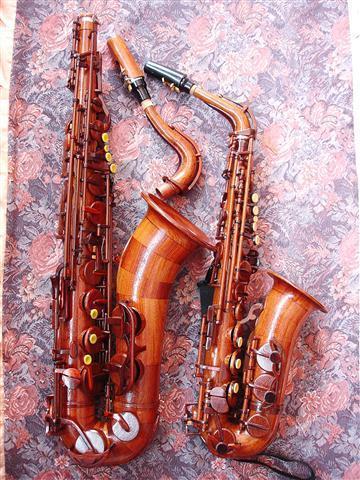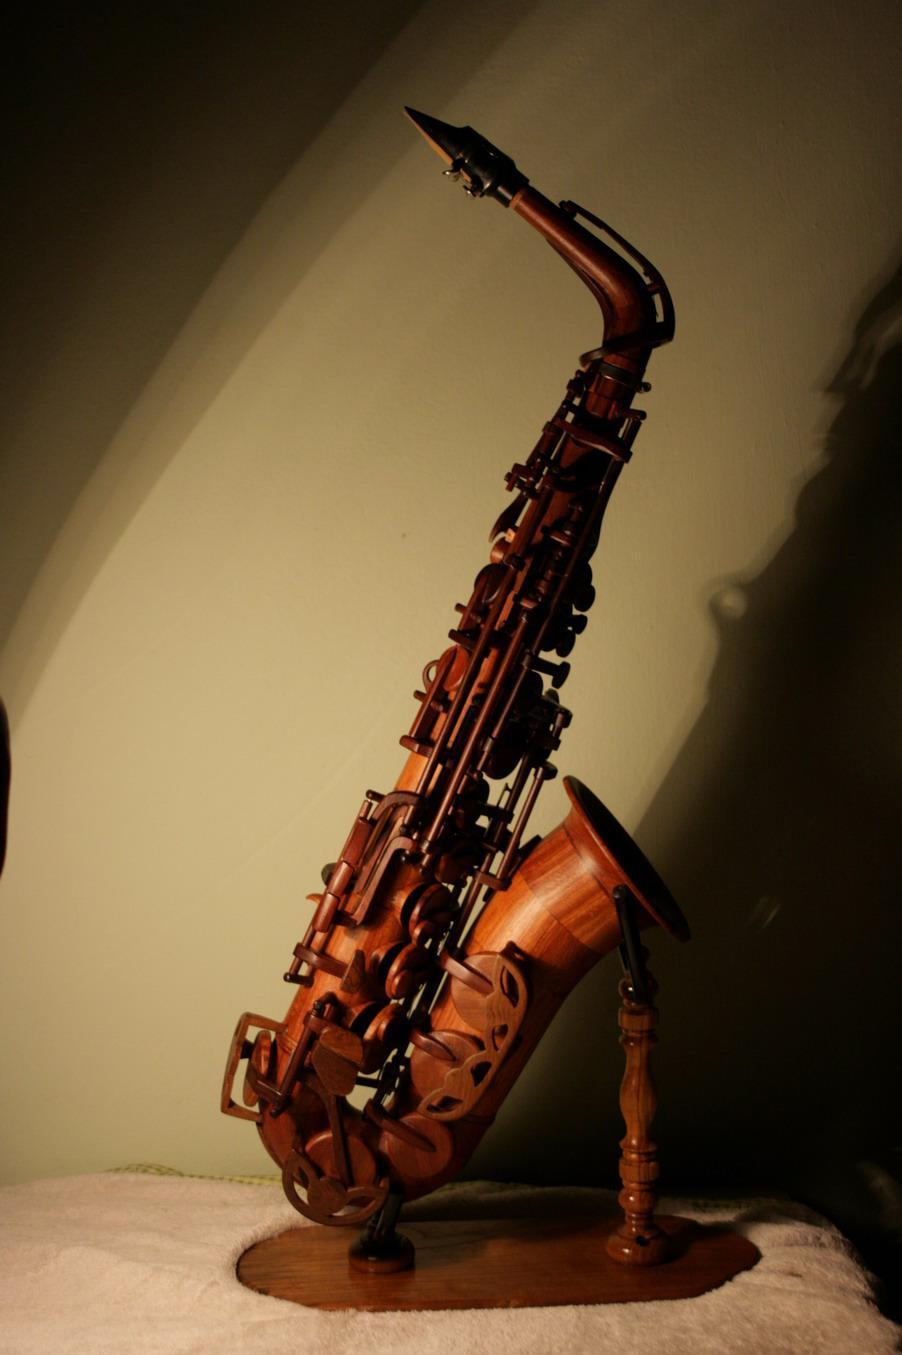The first image is the image on the left, the second image is the image on the right. Given the left and right images, does the statement "One of the images contains at least two saxophones." hold true? Answer yes or no. Yes. 